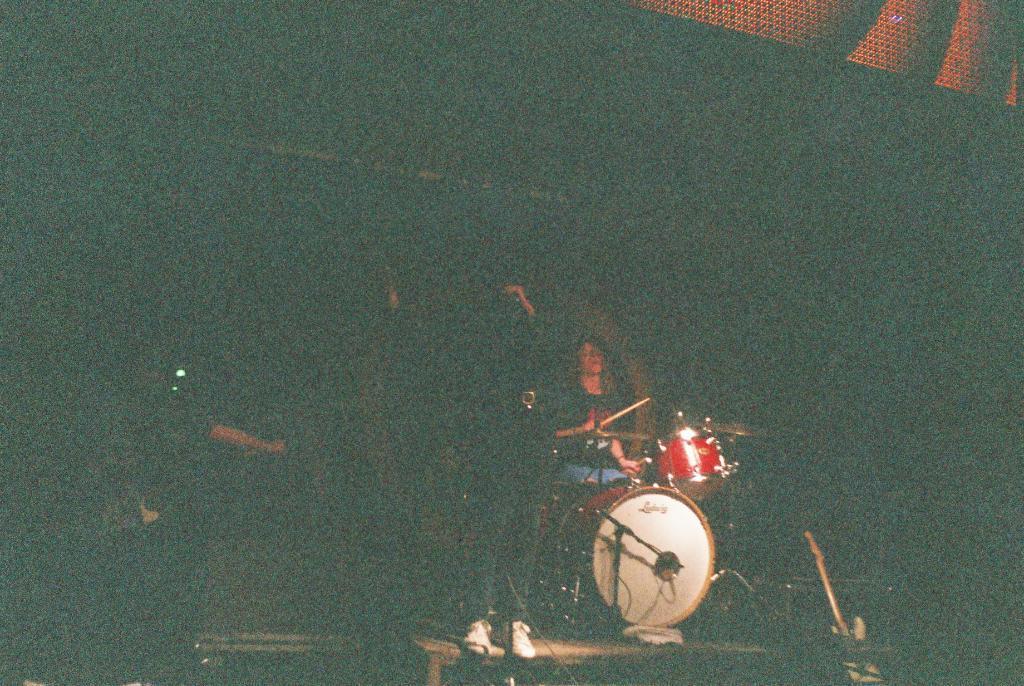Can you describe this image briefly? In the middle of the picture, we see a man is standing and he is holding a microphone in his hands. Beside him, we see a man is playing the musical instrument. In the background, it is black in color. In the right top, it is brown in color. This picture might be clicked in the dark. 